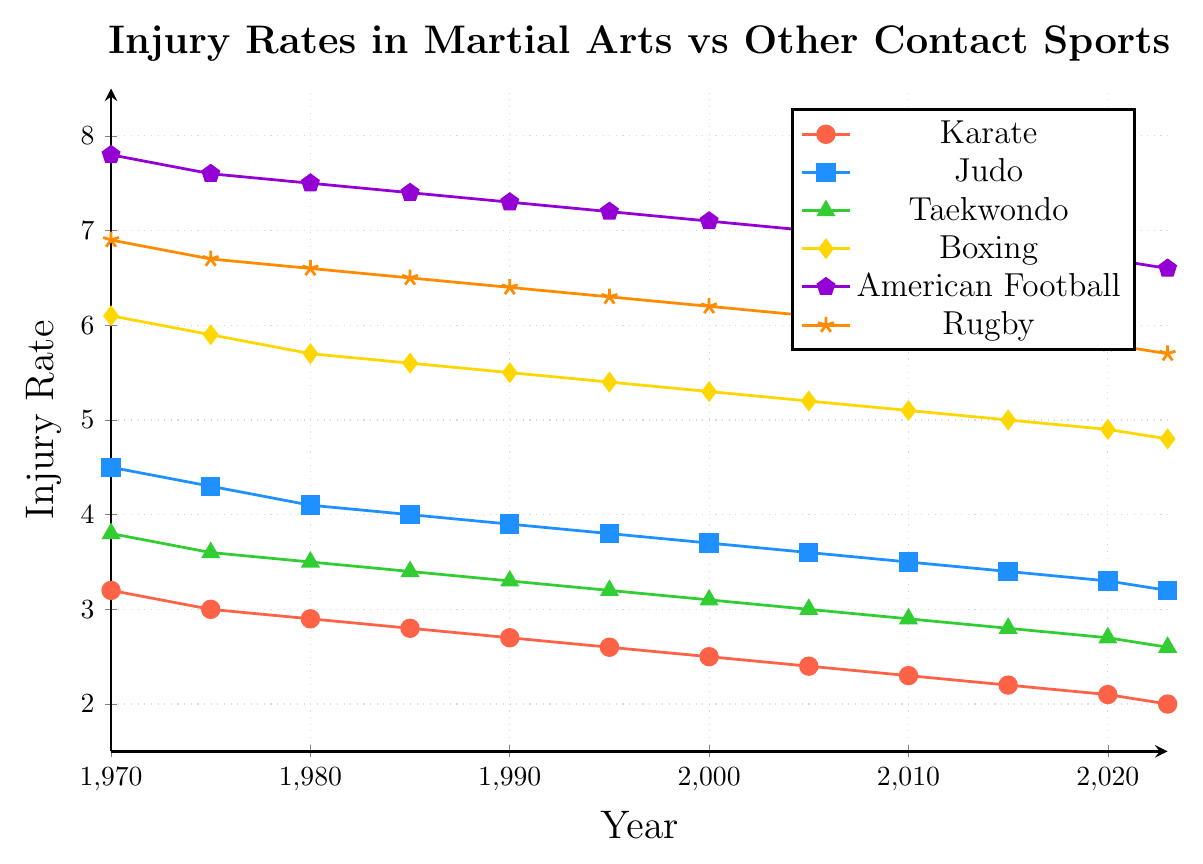What is the average injury rate for Karate from 1970 to 2023? To find the average, sum up all the injury rates and divide by the number of data points. The sum of Karate's injury rates is 3.2 + 3.0 + 2.9 + 2.8 + 2.7 + 2.6 + 2.5 + 2.4 + 2.3 + 2.2 + 2.1 + 2.0 = 34.7. There are 12 data points, so the average is 34.7 / 12 = 2.891.
Answer: 2.89 How have injury rates in Boxing changed from 1970 to 2023? To answer this, find the injury rates for Boxing in 1970 and 2023 and calculate the difference. In 1970, the rate was 6.1, and in 2023 it was 4.8. The change is 6.1 - 4.8 = 1.3.
Answer: Decreased by 1.3 Which sport had the highest injury rate in 1990? Look at the injury rates for all sports in the year 1990. The injury rates are Karate (2.7), Judo (3.9), Taekwondo (3.3), Boxing (5.5), American Football (7.3), and Rugby (6.4). The highest rate is 7.3 for American Football.
Answer: American Football What is the injury rate trend for Rugby from 1970 to 2023? Identify the injury rates of Rugby for each year and observe if they increase, decrease, or remain constant. The rates are: 6.9, 6.7, 6.6, 6.5, 6.4, 6.3, 6.2, 6.1, 6.0, 5.9, 5.8, 5.7. The trend shows a consistent decrease over the years.
Answer: Consistent decrease Compare average injury rates between Taekwondo and American Football. Calculate the average injury rates for both sports. Taekwondo has rates of 3.8, 3.6, 3.5, 3.4, 3.3, 3.2, 3.1, 3.0, 2.9, 2.8, 2.7, 2.6. The sum is 39.9, and the average is 39.9 / 12 = 3.325. American Football has rates of 7.8, 7.6, 7.5, 7.4, 7.3, 7.2, 7.1, 7.0, 6.9, 6.8, 6.7, 6.6. The sum is 87.9, and the average is 87.9 / 12 = 7.325.
Answer: 3.325 for Taekwondo and 7.325 for American Football By how much did the injury rate for Judo decrease from 1985 to 2005? Find the injury rates for Judo in 1985 and 2005. In 1985, the rate was 4.0, and in 2005 it was 3.6. The decrease is 4.0 - 3.6 = 0.4.
Answer: 0.4 Which sport had the least decrease in injury rates from 1970 to 2023? Calculate the difference in injury rates between 1970 and 2023 for all sports. Karate: 3.2 - 2.0 = 1.2, Judo: 4.5 - 3.2 = 1.3, Taekwondo: 3.8 - 2.6 = 1.2, Boxing: 6.1 - 4.8 = 1.3, American Football: 7.8 - 6.6 = 1.2, Rugby: 6.9 - 5.7 = 1.2. Multiple sports (Karate, Taekwondo, American Football, and Rugby) share the least decrease of 1.2.
Answer: Karate, Taekwondo, American Football, Rugby What is the overall trend for injury rates in Karate from 1970 to 2023? Observe the data points for Karate's injury rates over the years. The rates consistently decrease from 3.2 in 1970 to 2.0 in 2023.
Answer: Decreasing trend Which sport showed a greater reduction in injury rates from 1980 to 2020: Boxing or Rugby? Calculate the difference in injury rates between 1980 and 2020 for both sports. Boxing: 5.7 - 4.9 = 0.8 and Rugby: 6.6 - 5.8 = 0.8. Both sports showed the same reduction of 0.8.
Answer: Both showed a reduction of 0.8 